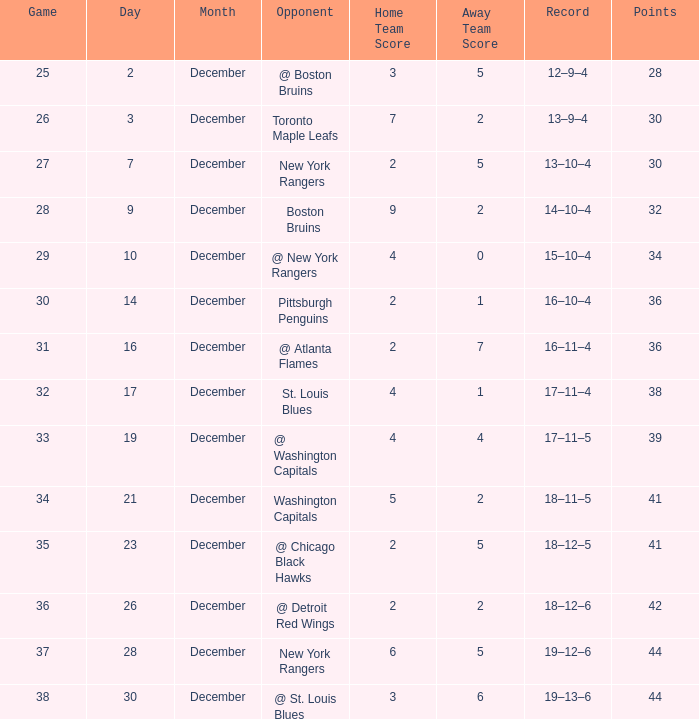Would you mind parsing the complete table? {'header': ['Game', 'Day', 'Month', 'Opponent', 'Home Team Score', 'Away Team Score', 'Record', 'Points'], 'rows': [['25', '2', 'December', '@ Boston Bruins', '3', '5', '12–9–4', '28'], ['26', '3', 'December', 'Toronto Maple Leafs', '7', '2', '13–9–4', '30'], ['27', '7', 'December', 'New York Rangers', '2', '5', '13–10–4', '30'], ['28', '9', 'December', 'Boston Bruins', '9', '2', '14–10–4', '32'], ['29', '10', 'December', '@ New York Rangers', '4', '0', '15–10–4', '34'], ['30', '14', 'December', 'Pittsburgh Penguins', '2', '1', '16–10–4', '36'], ['31', '16', 'December', '@ Atlanta Flames', '2', '7', '16–11–4', '36'], ['32', '17', 'December', 'St. Louis Blues', '4', '1', '17–11–4', '38'], ['33', '19', 'December', '@ Washington Capitals', '4', '4', '17–11–5', '39'], ['34', '21', 'December', 'Washington Capitals', '5', '2', '18–11–5', '41'], ['35', '23', 'December', '@ Chicago Black Hawks', '2', '5', '18–12–5', '41'], ['36', '26', 'December', '@ Detroit Red Wings', '2', '2', '18–12–6', '42'], ['37', '28', 'December', 'New York Rangers', '6', '5', '19–12–6', '44'], ['38', '30', 'December', '@ St. Louis Blues', '3', '6', '19–13–6', '44']]} Which game has a 14-10-4 record and a point total under 32? None. 